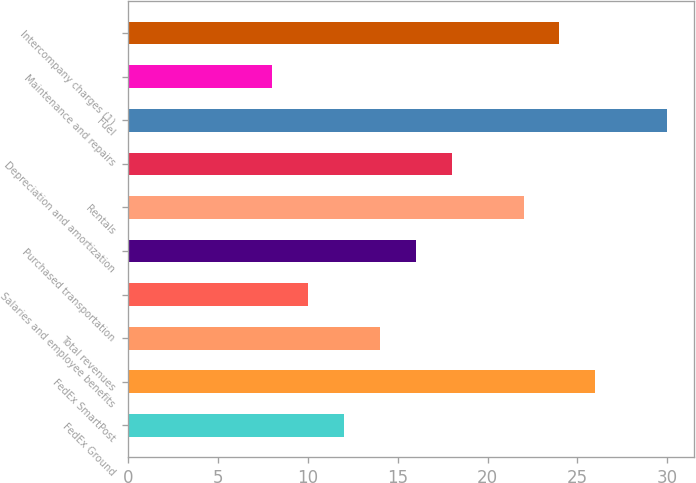Convert chart. <chart><loc_0><loc_0><loc_500><loc_500><bar_chart><fcel>FedEx Ground<fcel>FedEx SmartPost<fcel>Total revenues<fcel>Salaries and employee benefits<fcel>Purchased transportation<fcel>Rentals<fcel>Depreciation and amortization<fcel>Fuel<fcel>Maintenance and repairs<fcel>Intercompany charges (1)<nl><fcel>12<fcel>26<fcel>14<fcel>10<fcel>16<fcel>22<fcel>18<fcel>30<fcel>8<fcel>24<nl></chart> 